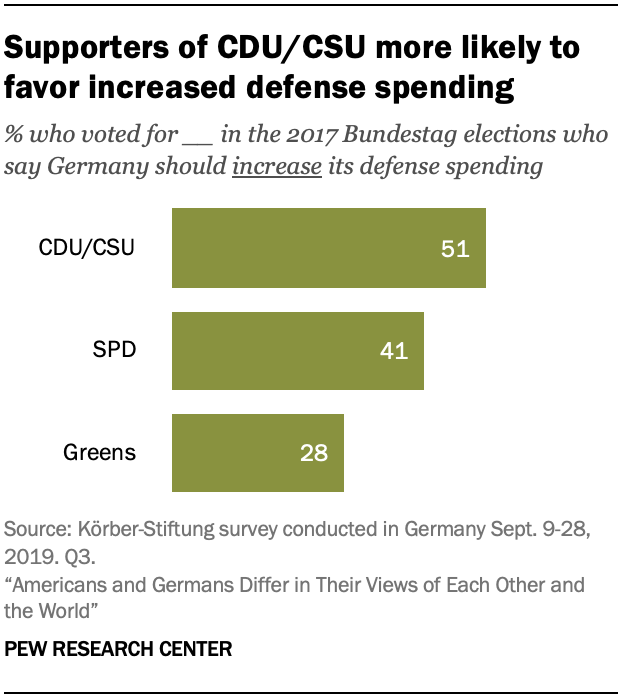Identify some key points in this picture. Approximately 40% of the options are the average. The option with the lowest amount is 'Greens'. 